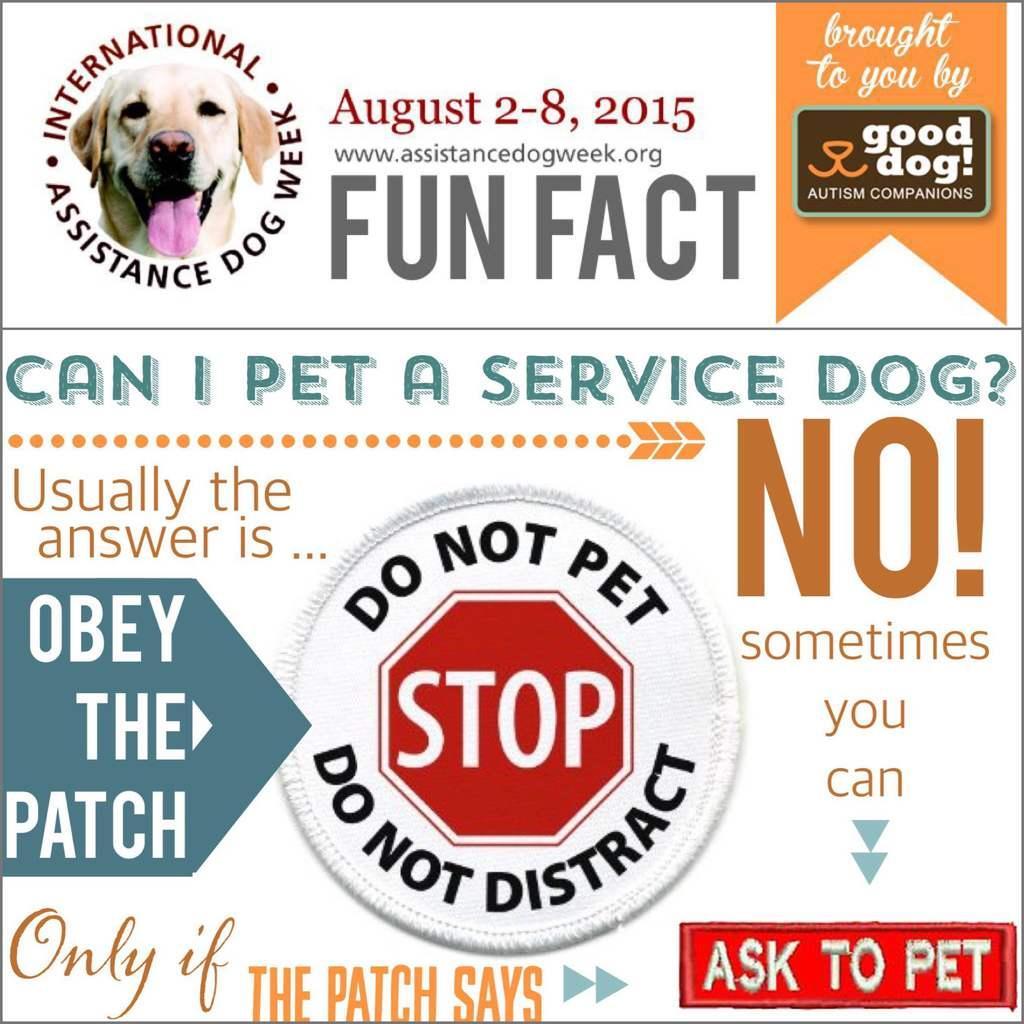Can you describe this image briefly? In this picture we can see a poster, on the poster we can see some text and image. 